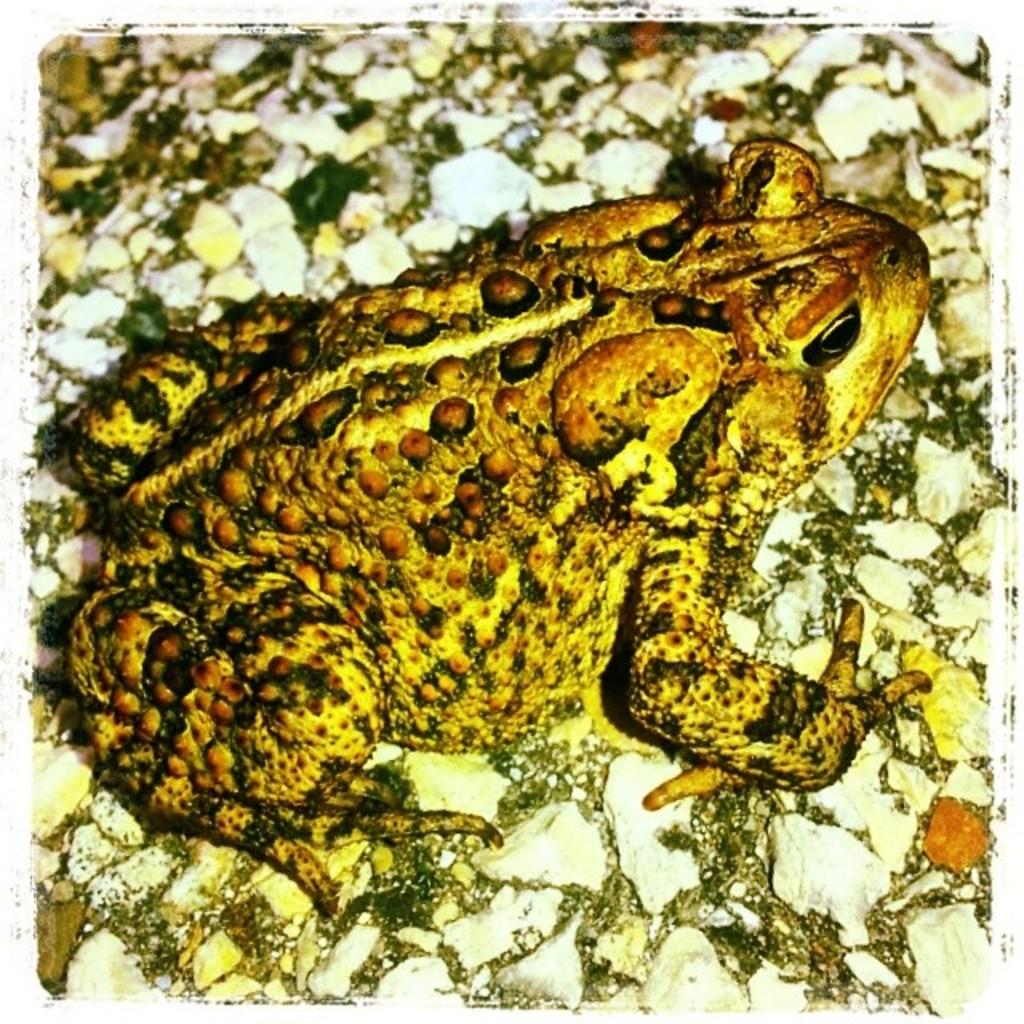What animal is present in the image? There is a frog in the image. Where is the frog located? The frog is on a rock surface. What are the markings on the frog? The frog has lines and dots on its body. What else can be seen on the rock surface? There are stones on the rock surface. What type of meat is being transported in a vase in the image? There is no meat or vase present in the image; it features a frog on a rock surface with lines and dots, along with stones on the rock surface. 